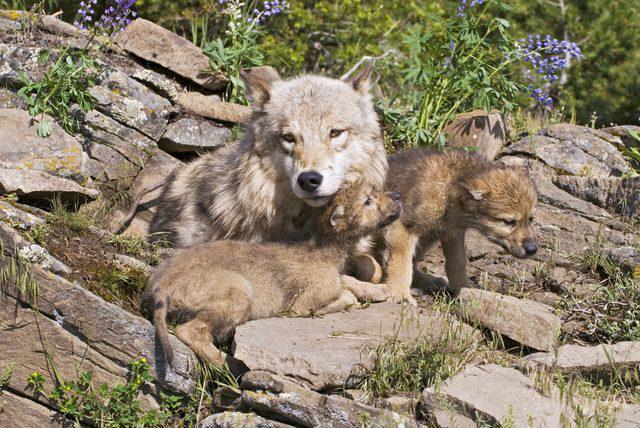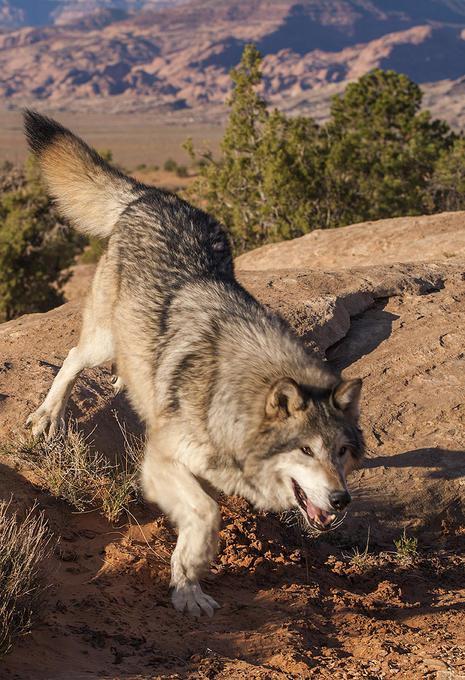The first image is the image on the left, the second image is the image on the right. Considering the images on both sides, is "Multiple wolves are depicted in the left image." valid? Answer yes or no. Yes. The first image is the image on the left, the second image is the image on the right. Considering the images on both sides, is "There are more than one animal in the image on the left." valid? Answer yes or no. Yes. 